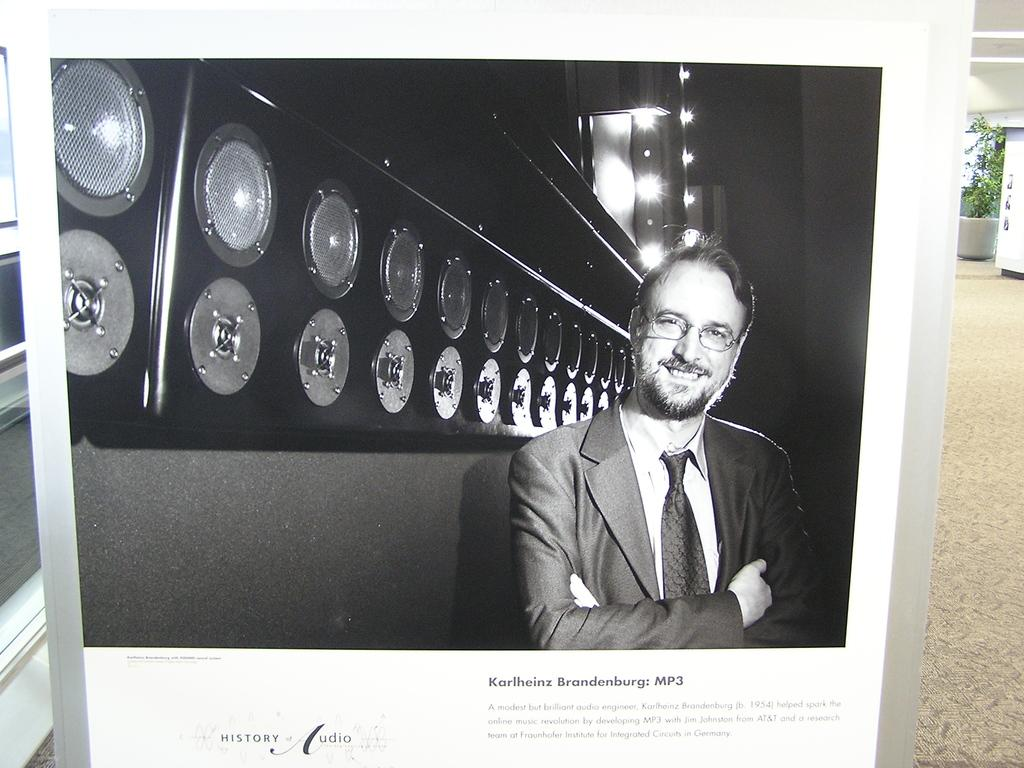What is the main subject of the image? There is a man in the image. What is the man doing in the image? The man is standing and smiling. What can be seen on the wall in the image? The wall has lights and speakers. What type of expert advice can be heard from the speakers in the image? There is no indication in the image that the speakers are playing any expert advice or information. 